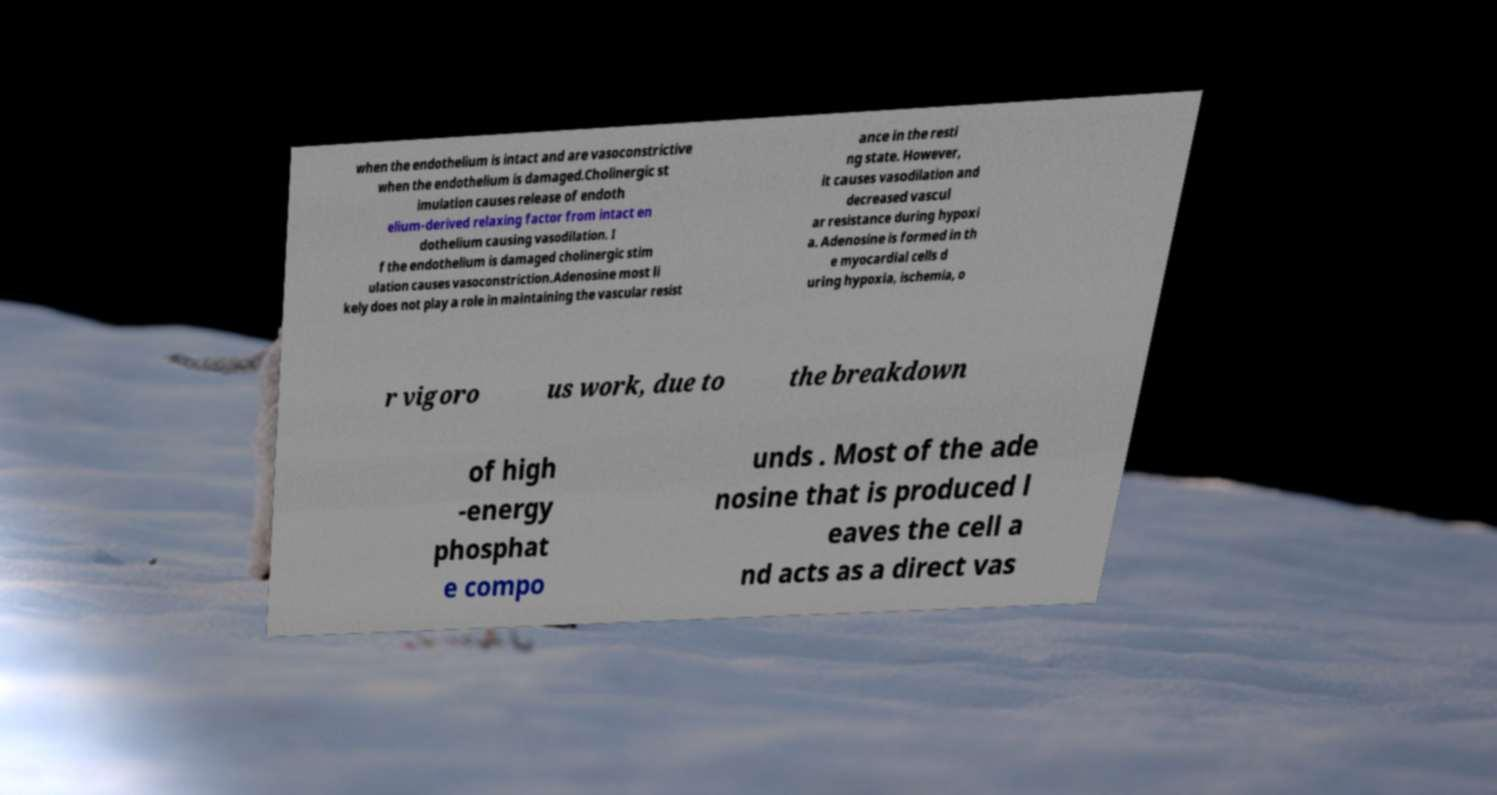I need the written content from this picture converted into text. Can you do that? when the endothelium is intact and are vasoconstrictive when the endothelium is damaged.Cholinergic st imulation causes release of endoth elium-derived relaxing factor from intact en dothelium causing vasodilation. I f the endothelium is damaged cholinergic stim ulation causes vasoconstriction.Adenosine most li kely does not play a role in maintaining the vascular resist ance in the resti ng state. However, it causes vasodilation and decreased vascul ar resistance during hypoxi a. Adenosine is formed in th e myocardial cells d uring hypoxia, ischemia, o r vigoro us work, due to the breakdown of high -energy phosphat e compo unds . Most of the ade nosine that is produced l eaves the cell a nd acts as a direct vas 